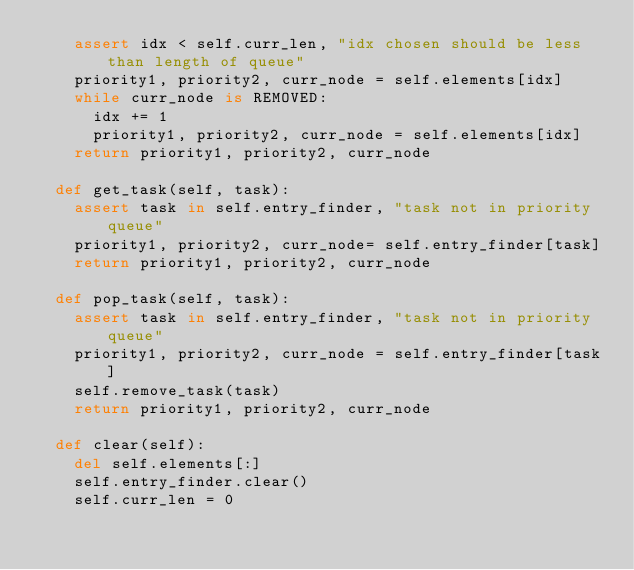Convert code to text. <code><loc_0><loc_0><loc_500><loc_500><_Python_>    assert idx < self.curr_len, "idx chosen should be less than length of queue"
    priority1, priority2, curr_node = self.elements[idx]
    while curr_node is REMOVED:
      idx += 1
      priority1, priority2, curr_node = self.elements[idx]
    return priority1, priority2, curr_node

  def get_task(self, task):
    assert task in self.entry_finder, "task not in priority queue"
    priority1, priority2, curr_node= self.entry_finder[task]
    return priority1, priority2, curr_node

  def pop_task(self, task):
    assert task in self.entry_finder, "task not in priority queue"
    priority1, priority2, curr_node = self.entry_finder[task]
    self.remove_task(task)
    return priority1, priority2, curr_node

  def clear(self):
    del self.elements[:]
    self.entry_finder.clear()
    self.curr_len = 0
</code> 